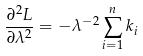<formula> <loc_0><loc_0><loc_500><loc_500>\frac { \partial ^ { 2 } L } { \partial \lambda ^ { 2 } } = - \lambda ^ { - 2 } \sum _ { i = 1 } ^ { n } k _ { i }</formula> 